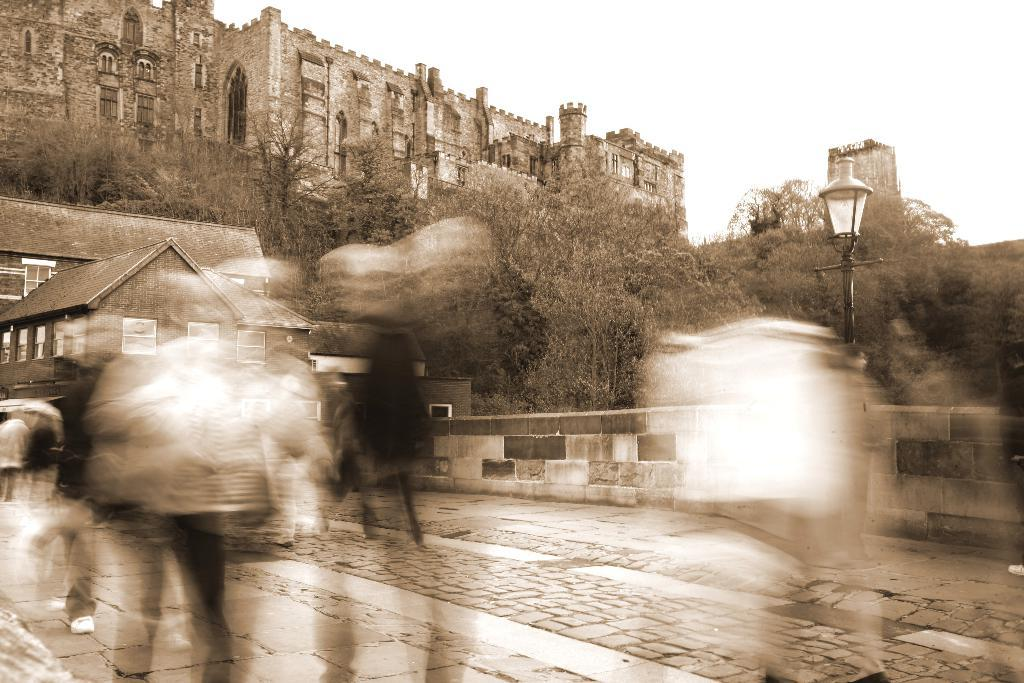What type of structure is visible in the image? There is a fort in the image. What other type of structure can be seen in the image? There is a house in the image. What object is present in the image that might be used for communication or displaying information? There is a pole in the image. What is attached to the pole in the image? There is a light in the image. Are there any living beings in the image? Yes, there are people in the image. What type of beginner's mistake can be seen in the image? There is no beginner's mistake present in the image. Can you see the tongue of the ghost in the image? There is no ghost or tongue present in the image. 